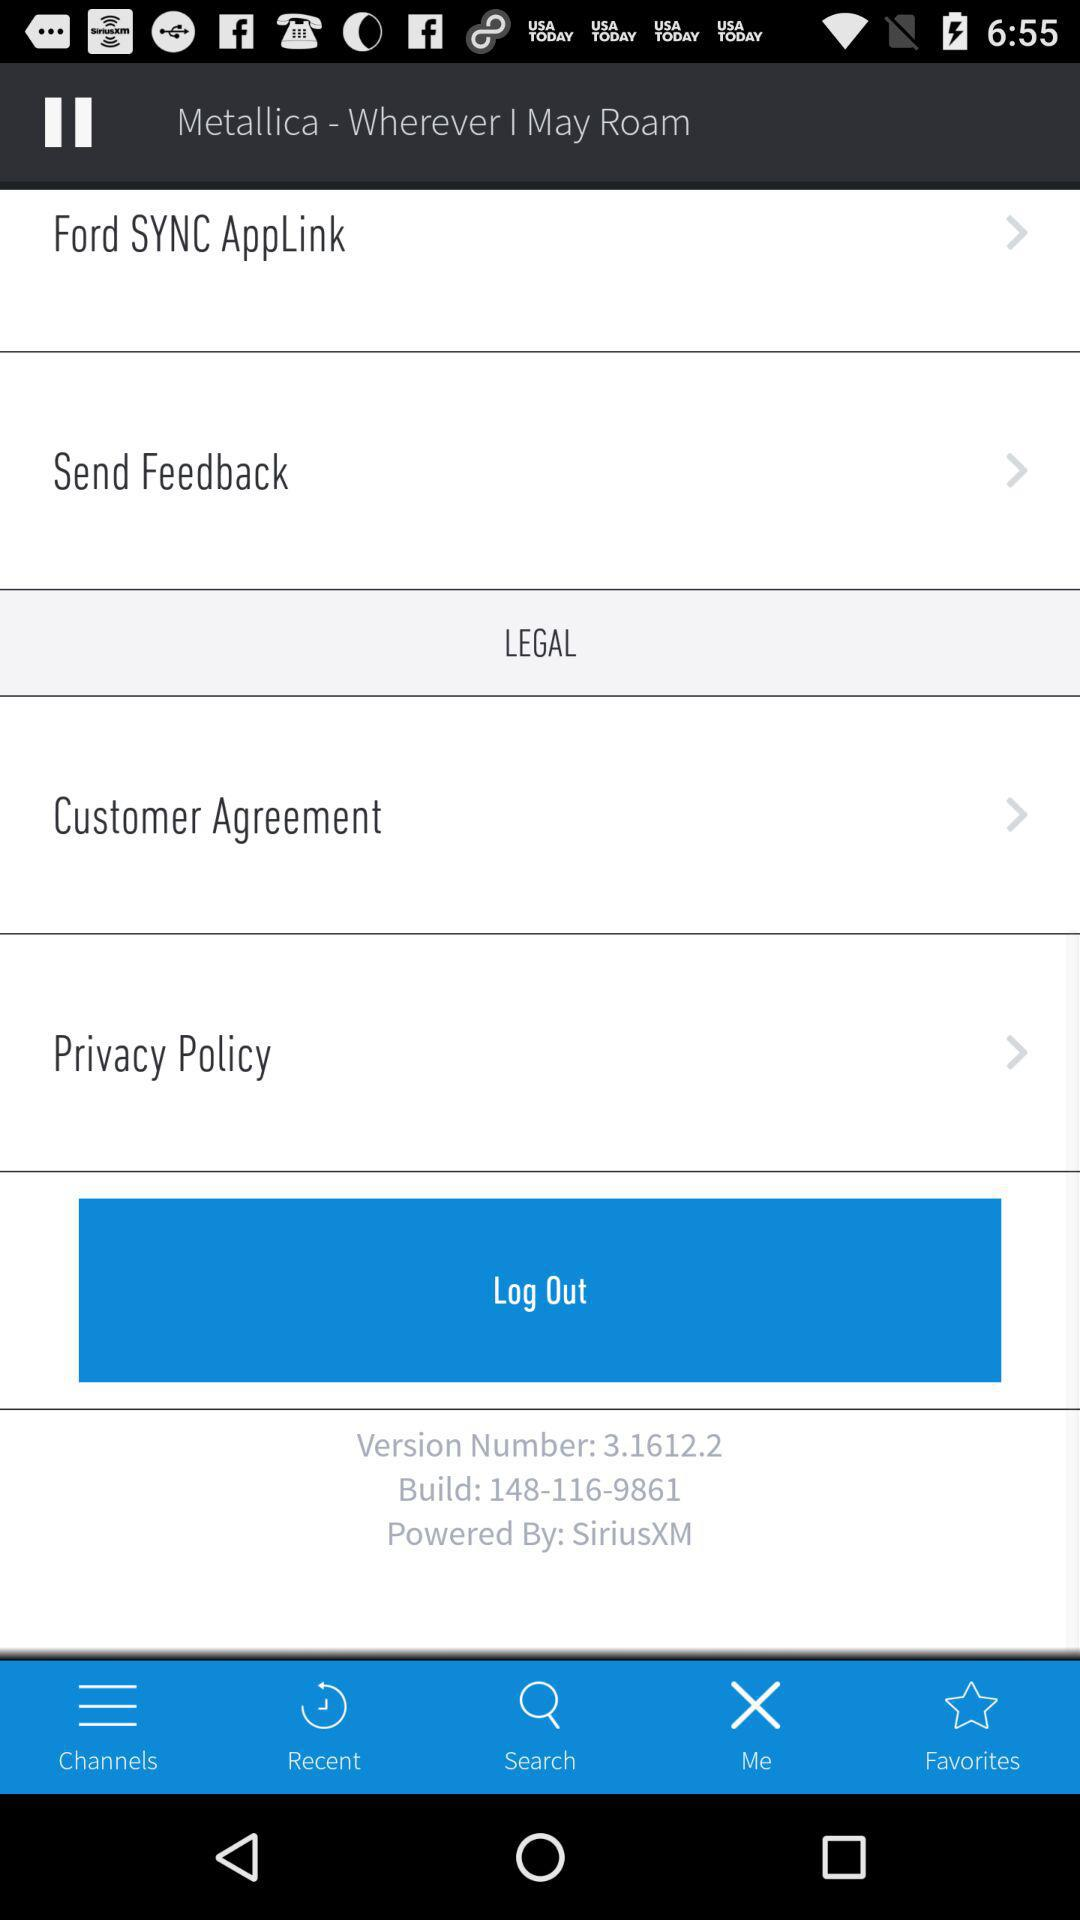What is the phone number to cancel a subscription? The phone number is 1-866-635-2349. 